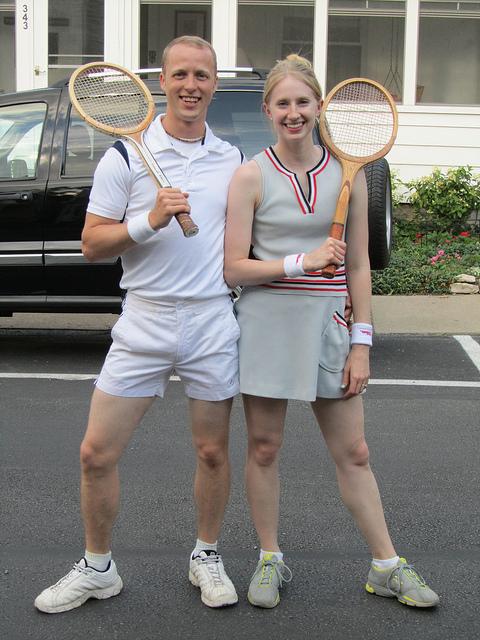What type of scene is this?
Write a very short answer. Tennis. What are the people holding?
Quick response, please. Tennis rackets. Are they a couple?
Keep it brief. Yes. 